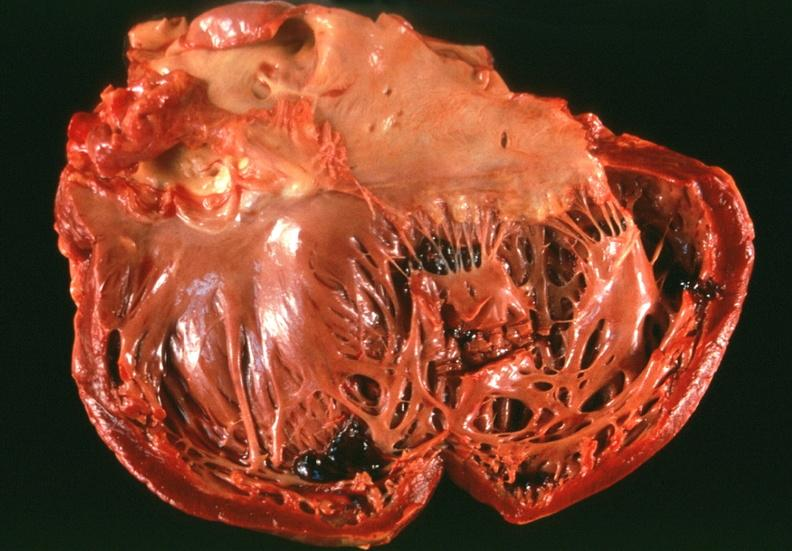s cardiovascular present?
Answer the question using a single word or phrase. Yes 